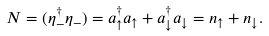<formula> <loc_0><loc_0><loc_500><loc_500>N = ( \eta _ { - } ^ { \dagger } \eta _ { - } ) = a _ { \uparrow } ^ { \dagger } a _ { \uparrow } + a _ { \downarrow } ^ { \dagger } a _ { \downarrow } = n _ { \uparrow } + n _ { \downarrow } .</formula> 